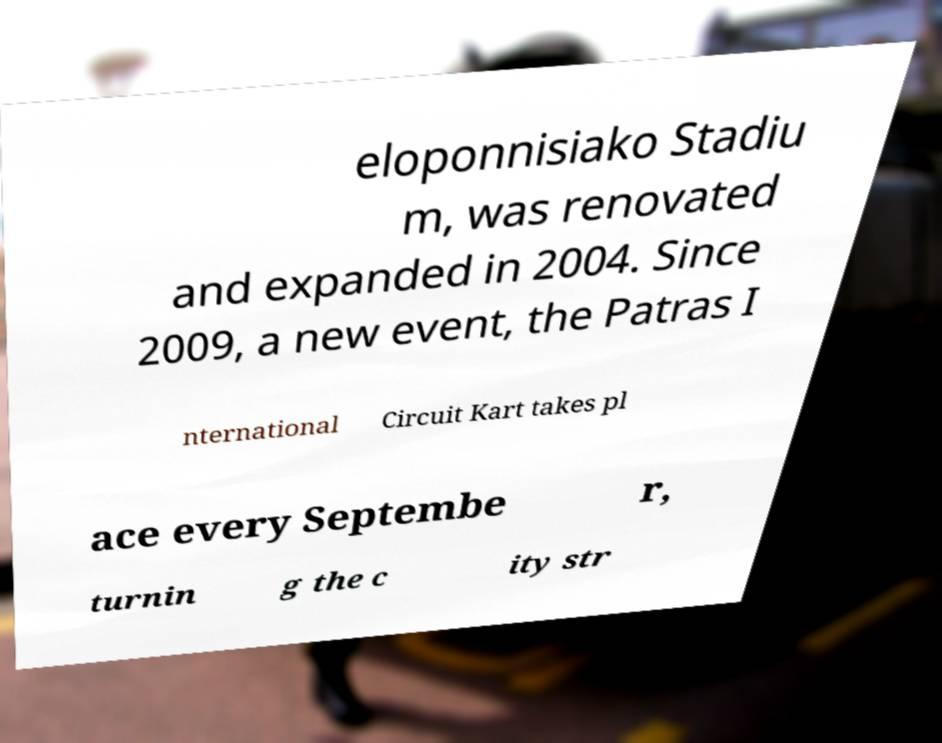Please identify and transcribe the text found in this image. eloponnisiako Stadiu m, was renovated and expanded in 2004. Since 2009, a new event, the Patras I nternational Circuit Kart takes pl ace every Septembe r, turnin g the c ity str 